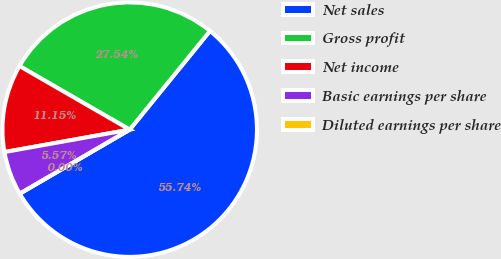Convert chart to OTSL. <chart><loc_0><loc_0><loc_500><loc_500><pie_chart><fcel>Net sales<fcel>Gross profit<fcel>Net income<fcel>Basic earnings per share<fcel>Diluted earnings per share<nl><fcel>55.74%<fcel>27.54%<fcel>11.15%<fcel>5.57%<fcel>0.0%<nl></chart> 